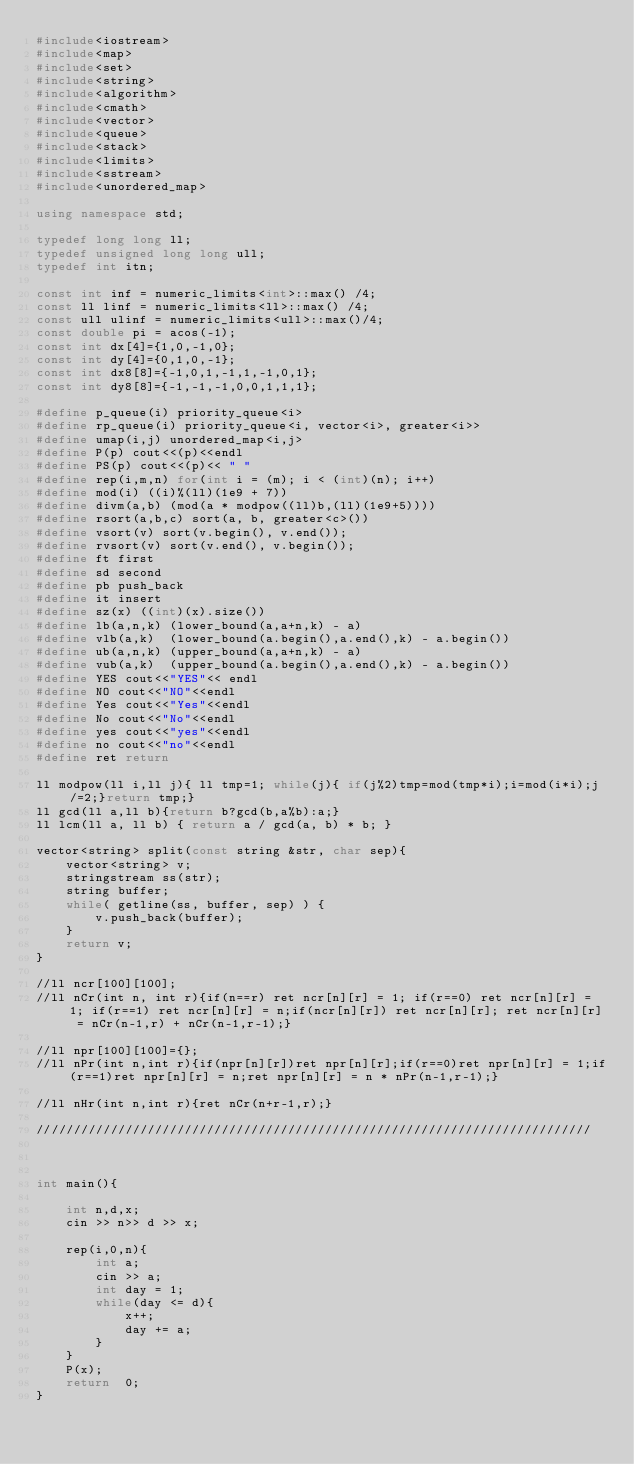Convert code to text. <code><loc_0><loc_0><loc_500><loc_500><_C++_>#include<iostream>
#include<map>
#include<set>
#include<string>
#include<algorithm>
#include<cmath>
#include<vector>
#include<queue>
#include<stack>
#include<limits>
#include<sstream> 
#include<unordered_map>      

using namespace std;

typedef long long ll;
typedef unsigned long long ull;
typedef int itn;

const int inf = numeric_limits<int>::max() /4;
const ll linf = numeric_limits<ll>::max() /4;
const ull ulinf = numeric_limits<ull>::max()/4;
const double pi = acos(-1);
const int dx[4]={1,0,-1,0};
const int dy[4]={0,1,0,-1};
const int dx8[8]={-1,0,1,-1,1,-1,0,1};
const int dy8[8]={-1,-1,-1,0,0,1,1,1};

#define p_queue(i) priority_queue<i> 
#define rp_queue(i) priority_queue<i, vector<i>, greater<i>> 
#define umap(i,j) unordered_map<i,j>
#define P(p) cout<<(p)<<endl
#define PS(p) cout<<(p)<< " "
#define rep(i,m,n) for(int i = (m); i < (int)(n); i++)
#define mod(i) ((i)%(ll)(1e9 + 7))
#define divm(a,b) (mod(a * modpow((ll)b,(ll)(1e9+5))))
#define rsort(a,b,c) sort(a, b, greater<c>())
#define vsort(v) sort(v.begin(), v.end());
#define rvsort(v) sort(v.end(), v.begin());
#define ft first
#define sd second
#define pb push_back
#define it insert
#define sz(x) ((int)(x).size())
#define lb(a,n,k) (lower_bound(a,a+n,k) - a) 
#define vlb(a,k)  (lower_bound(a.begin(),a.end(),k) - a.begin())
#define ub(a,n,k) (upper_bound(a,a+n,k) - a) 
#define vub(a,k)  (upper_bound(a.begin(),a.end(),k) - a.begin())
#define YES cout<<"YES"<< endl
#define NO cout<<"NO"<<endl
#define Yes cout<<"Yes"<<endl
#define No cout<<"No"<<endl  
#define yes cout<<"yes"<<endl
#define no cout<<"no"<<endl
#define ret return

ll modpow(ll i,ll j){ ll tmp=1; while(j){ if(j%2)tmp=mod(tmp*i);i=mod(i*i);j/=2;}return tmp;}
ll gcd(ll a,ll b){return b?gcd(b,a%b):a;}
ll lcm(ll a, ll b) { return a / gcd(a, b) * b; }

vector<string> split(const string &str, char sep){
    vector<string> v;
    stringstream ss(str);
    string buffer;
    while( getline(ss, buffer, sep) ) {
        v.push_back(buffer);
    }
    return v;
}

//ll ncr[100][100];
//ll nCr(int n, int r){if(n==r) ret ncr[n][r] = 1; if(r==0) ret ncr[n][r] = 1; if(r==1) ret ncr[n][r] = n;if(ncr[n][r]) ret ncr[n][r]; ret ncr[n][r] = nCr(n-1,r) + nCr(n-1,r-1);}

//ll npr[100][100]={};
//ll nPr(int n,int r){if(npr[n][r])ret npr[n][r];if(r==0)ret npr[n][r] = 1;if(r==1)ret npr[n][r] = n;ret npr[n][r] = n * nPr(n-1,r-1);}

//ll nHr(int n,int r){ret nCr(n+r-1,r);}

///////////////////////////////////////////////////////////////////////////



int main(){
    
    int n,d,x;
    cin >> n>> d >> x;

    rep(i,0,n){
        int a;
        cin >> a;
        int day = 1;
        while(day <= d){
            x++;
            day += a;
        }
    }
	P(x);
	return  0;
}</code> 